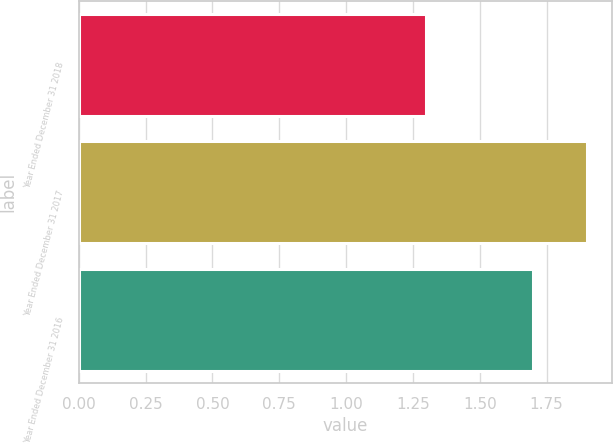<chart> <loc_0><loc_0><loc_500><loc_500><bar_chart><fcel>Year Ended December 31 2018<fcel>Year Ended December 31 2017<fcel>Year Ended December 31 2016<nl><fcel>1.3<fcel>1.9<fcel>1.7<nl></chart> 